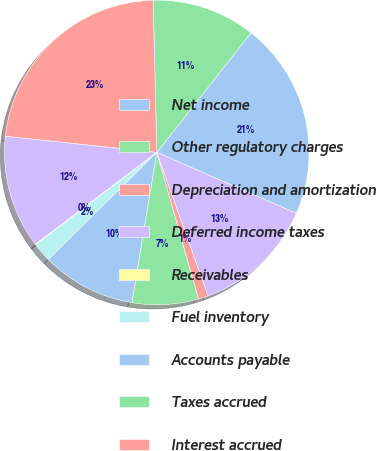Convert chart. <chart><loc_0><loc_0><loc_500><loc_500><pie_chart><fcel>Net income<fcel>Other regulatory charges<fcel>Depreciation and amortization<fcel>Deferred income taxes<fcel>Receivables<fcel>Fuel inventory<fcel>Accounts payable<fcel>Taxes accrued<fcel>Interest accrued<fcel>Deferred fuel costs<nl><fcel>20.94%<fcel>10.99%<fcel>22.93%<fcel>11.99%<fcel>0.05%<fcel>2.04%<fcel>10.0%<fcel>7.02%<fcel>1.05%<fcel>12.98%<nl></chart> 